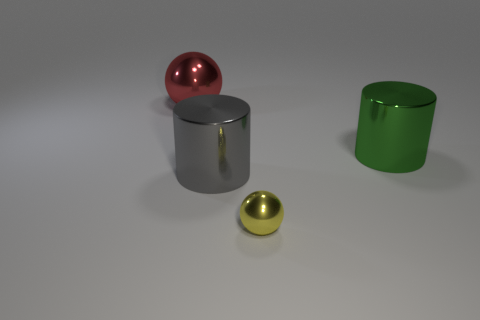Add 1 small rubber cubes. How many objects exist? 5 Subtract 0 cyan blocks. How many objects are left? 4 Subtract all big gray metallic objects. Subtract all green cylinders. How many objects are left? 2 Add 1 small yellow objects. How many small yellow objects are left? 2 Add 1 large metal spheres. How many large metal spheres exist? 2 